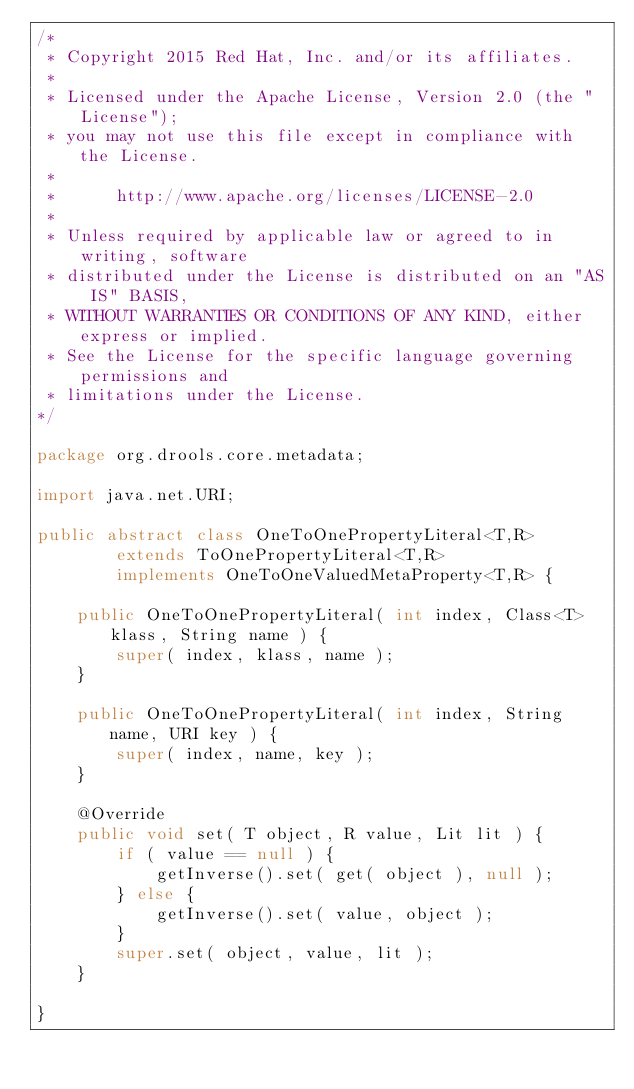Convert code to text. <code><loc_0><loc_0><loc_500><loc_500><_Java_>/*
 * Copyright 2015 Red Hat, Inc. and/or its affiliates.
 *
 * Licensed under the Apache License, Version 2.0 (the "License");
 * you may not use this file except in compliance with the License.
 * 
 *      http://www.apache.org/licenses/LICENSE-2.0
 *
 * Unless required by applicable law or agreed to in writing, software
 * distributed under the License is distributed on an "AS IS" BASIS,
 * WITHOUT WARRANTIES OR CONDITIONS OF ANY KIND, either express or implied.
 * See the License for the specific language governing permissions and
 * limitations under the License.
*/

package org.drools.core.metadata;

import java.net.URI;

public abstract class OneToOnePropertyLiteral<T,R>
        extends ToOnePropertyLiteral<T,R>
        implements OneToOneValuedMetaProperty<T,R> {

    public OneToOnePropertyLiteral( int index, Class<T> klass, String name ) {
        super( index, klass, name );
    }

    public OneToOnePropertyLiteral( int index, String name, URI key ) {
        super( index, name, key );
    }

    @Override
    public void set( T object, R value, Lit lit ) {
        if ( value == null ) {
            getInverse().set( get( object ), null );
        } else {
            getInverse().set( value, object );
        }
        super.set( object, value, lit );
    }

}
</code> 